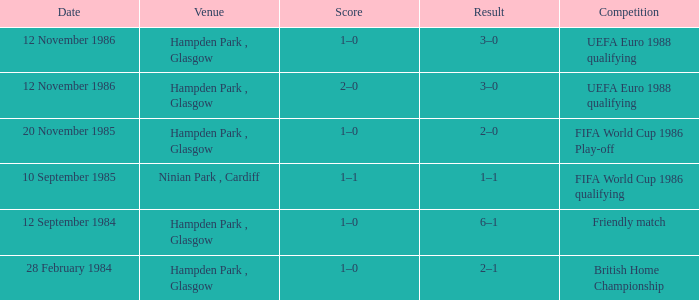What is the Score of the Fifa World Cup 1986 Qualifying Competition? 1–1. 